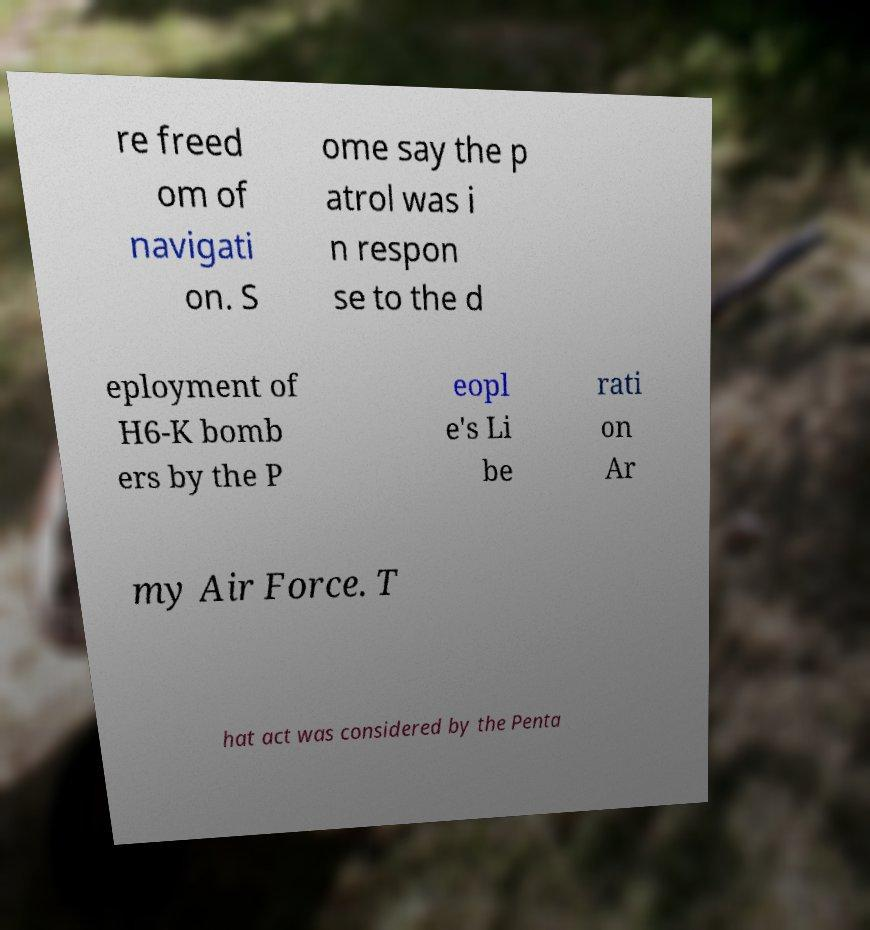Please identify and transcribe the text found in this image. re freed om of navigati on. S ome say the p atrol was i n respon se to the d eployment of H6-K bomb ers by the P eopl e's Li be rati on Ar my Air Force. T hat act was considered by the Penta 